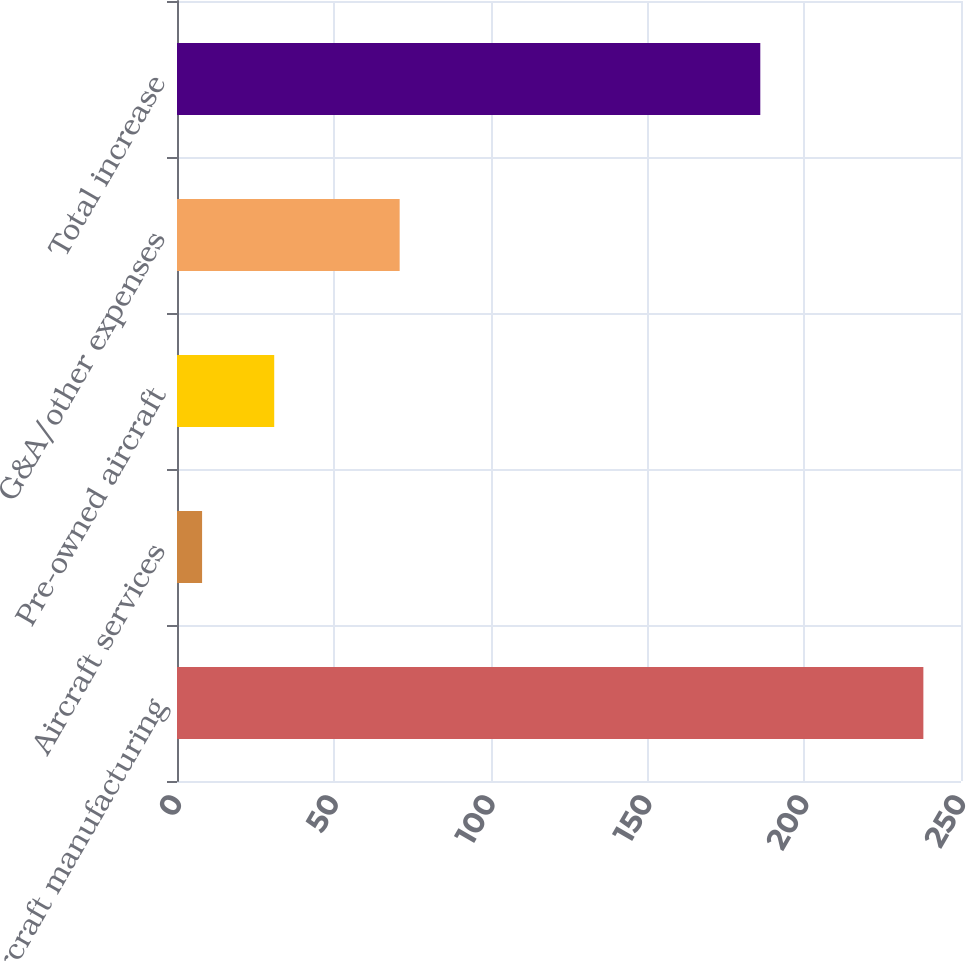Convert chart to OTSL. <chart><loc_0><loc_0><loc_500><loc_500><bar_chart><fcel>Aircraft manufacturing<fcel>Aircraft services<fcel>Pre-owned aircraft<fcel>G&A/other expenses<fcel>Total increase<nl><fcel>238<fcel>8<fcel>31<fcel>71<fcel>186<nl></chart> 